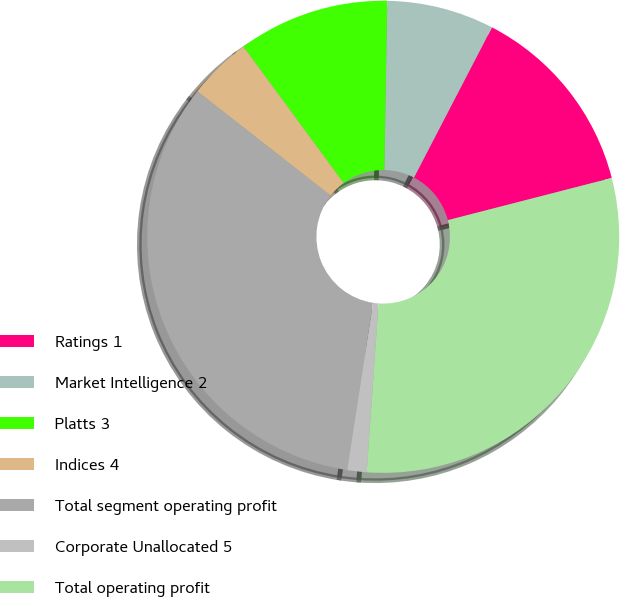Convert chart. <chart><loc_0><loc_0><loc_500><loc_500><pie_chart><fcel>Ratings 1<fcel>Market Intelligence 2<fcel>Platts 3<fcel>Indices 4<fcel>Total segment operating profit<fcel>Corporate Unallocated 5<fcel>Total operating profit<nl><fcel>13.37%<fcel>7.35%<fcel>10.36%<fcel>4.34%<fcel>33.13%<fcel>1.33%<fcel>30.12%<nl></chart> 